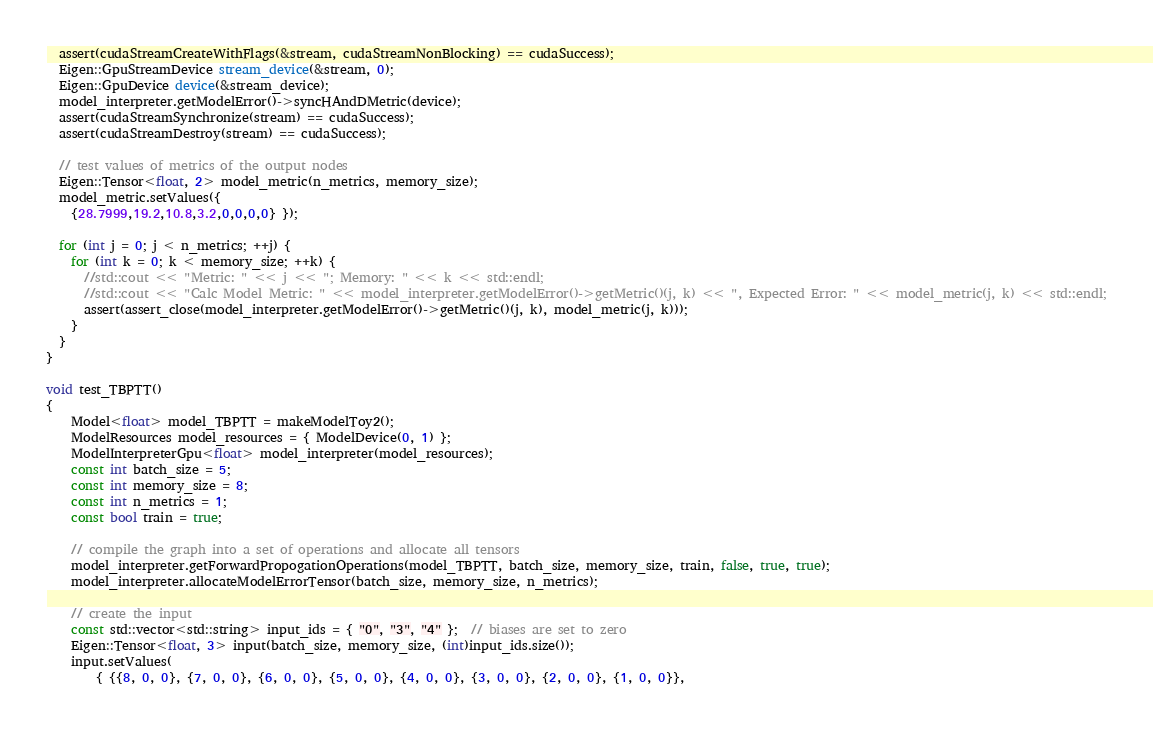Convert code to text. <code><loc_0><loc_0><loc_500><loc_500><_Cuda_>  assert(cudaStreamCreateWithFlags(&stream, cudaStreamNonBlocking) == cudaSuccess);
  Eigen::GpuStreamDevice stream_device(&stream, 0);
  Eigen::GpuDevice device(&stream_device);
  model_interpreter.getModelError()->syncHAndDMetric(device);
  assert(cudaStreamSynchronize(stream) == cudaSuccess);
  assert(cudaStreamDestroy(stream) == cudaSuccess);

  // test values of metrics of the output nodes
  Eigen::Tensor<float, 2> model_metric(n_metrics, memory_size);
  model_metric.setValues({
    {28.7999,19.2,10.8,3.2,0,0,0,0} });

  for (int j = 0; j < n_metrics; ++j) {
    for (int k = 0; k < memory_size; ++k) {
      //std::cout << "Metric: " << j << "; Memory: " << k << std::endl;
      //std::cout << "Calc Model Metric: " << model_interpreter.getModelError()->getMetric()(j, k) << ", Expected Error: " << model_metric(j, k) << std::endl;
      assert(assert_close(model_interpreter.getModelError()->getMetric()(j, k), model_metric(j, k)));
    }
  }
}

void test_TBPTT()
{
	Model<float> model_TBPTT = makeModelToy2();
	ModelResources model_resources = { ModelDevice(0, 1) };
	ModelInterpreterGpu<float> model_interpreter(model_resources);
	const int batch_size = 5;
	const int memory_size = 8;
	const int n_metrics = 1;
	const bool train = true;

	// compile the graph into a set of operations and allocate all tensors
	model_interpreter.getForwardPropogationOperations(model_TBPTT, batch_size, memory_size, train, false, true, true);
	model_interpreter.allocateModelErrorTensor(batch_size, memory_size, n_metrics);

	// create the input
	const std::vector<std::string> input_ids = { "0", "3", "4" };  // biases are set to zero
	Eigen::Tensor<float, 3> input(batch_size, memory_size, (int)input_ids.size());
	input.setValues(
		{ {{8, 0, 0}, {7, 0, 0}, {6, 0, 0}, {5, 0, 0}, {4, 0, 0}, {3, 0, 0}, {2, 0, 0}, {1, 0, 0}},</code> 